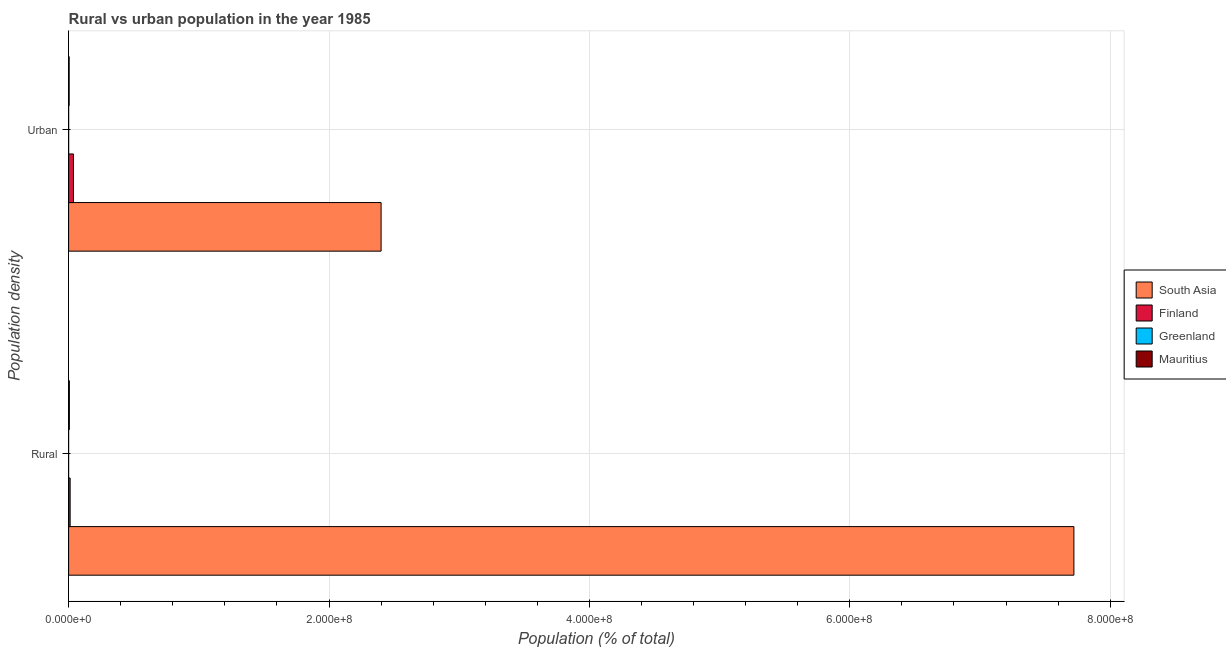How many different coloured bars are there?
Provide a short and direct response. 4. How many groups of bars are there?
Your response must be concise. 2. What is the label of the 2nd group of bars from the top?
Provide a succinct answer. Rural. What is the urban population density in Greenland?
Provide a succinct answer. 4.15e+04. Across all countries, what is the maximum urban population density?
Offer a terse response. 2.40e+08. Across all countries, what is the minimum rural population density?
Offer a terse response. 1.17e+04. In which country was the urban population density maximum?
Your answer should be very brief. South Asia. In which country was the rural population density minimum?
Make the answer very short. Greenland. What is the total rural population density in the graph?
Keep it short and to the point. 7.74e+08. What is the difference between the urban population density in Finland and that in Greenland?
Provide a short and direct response. 3.67e+06. What is the difference between the rural population density in Finland and the urban population density in South Asia?
Make the answer very short. -2.39e+08. What is the average urban population density per country?
Give a very brief answer. 6.10e+07. What is the difference between the rural population density and urban population density in Finland?
Provide a succinct answer. -2.53e+06. What is the ratio of the urban population density in Mauritius to that in Finland?
Provide a succinct answer. 0.12. Is the urban population density in Finland less than that in Mauritius?
Your answer should be very brief. No. In how many countries, is the urban population density greater than the average urban population density taken over all countries?
Keep it short and to the point. 1. What does the 3rd bar from the bottom in Urban represents?
Ensure brevity in your answer.  Greenland. How many countries are there in the graph?
Provide a succinct answer. 4. What is the difference between two consecutive major ticks on the X-axis?
Give a very brief answer. 2.00e+08. How many legend labels are there?
Give a very brief answer. 4. How are the legend labels stacked?
Provide a short and direct response. Vertical. What is the title of the graph?
Your response must be concise. Rural vs urban population in the year 1985. What is the label or title of the X-axis?
Offer a very short reply. Population (% of total). What is the label or title of the Y-axis?
Make the answer very short. Population density. What is the Population (% of total) of South Asia in Rural?
Provide a short and direct response. 7.72e+08. What is the Population (% of total) of Finland in Rural?
Make the answer very short. 1.19e+06. What is the Population (% of total) of Greenland in Rural?
Provide a succinct answer. 1.17e+04. What is the Population (% of total) in Mauritius in Rural?
Your answer should be very brief. 5.89e+05. What is the Population (% of total) in South Asia in Urban?
Offer a very short reply. 2.40e+08. What is the Population (% of total) in Finland in Urban?
Provide a short and direct response. 3.72e+06. What is the Population (% of total) in Greenland in Urban?
Your answer should be compact. 4.15e+04. What is the Population (% of total) in Mauritius in Urban?
Your answer should be compact. 4.32e+05. Across all Population density, what is the maximum Population (% of total) in South Asia?
Your answer should be compact. 7.72e+08. Across all Population density, what is the maximum Population (% of total) of Finland?
Give a very brief answer. 3.72e+06. Across all Population density, what is the maximum Population (% of total) in Greenland?
Make the answer very short. 4.15e+04. Across all Population density, what is the maximum Population (% of total) in Mauritius?
Your answer should be very brief. 5.89e+05. Across all Population density, what is the minimum Population (% of total) in South Asia?
Ensure brevity in your answer.  2.40e+08. Across all Population density, what is the minimum Population (% of total) in Finland?
Provide a succinct answer. 1.19e+06. Across all Population density, what is the minimum Population (% of total) in Greenland?
Ensure brevity in your answer.  1.17e+04. Across all Population density, what is the minimum Population (% of total) of Mauritius?
Your answer should be compact. 4.32e+05. What is the total Population (% of total) in South Asia in the graph?
Your response must be concise. 1.01e+09. What is the total Population (% of total) in Finland in the graph?
Give a very brief answer. 4.90e+06. What is the total Population (% of total) of Greenland in the graph?
Your response must be concise. 5.32e+04. What is the total Population (% of total) of Mauritius in the graph?
Give a very brief answer. 1.02e+06. What is the difference between the Population (% of total) of South Asia in Rural and that in Urban?
Ensure brevity in your answer.  5.32e+08. What is the difference between the Population (% of total) of Finland in Rural and that in Urban?
Offer a very short reply. -2.53e+06. What is the difference between the Population (% of total) of Greenland in Rural and that in Urban?
Offer a terse response. -2.98e+04. What is the difference between the Population (% of total) of Mauritius in Rural and that in Urban?
Provide a succinct answer. 1.57e+05. What is the difference between the Population (% of total) in South Asia in Rural and the Population (% of total) in Finland in Urban?
Make the answer very short. 7.68e+08. What is the difference between the Population (% of total) in South Asia in Rural and the Population (% of total) in Greenland in Urban?
Provide a short and direct response. 7.72e+08. What is the difference between the Population (% of total) of South Asia in Rural and the Population (% of total) of Mauritius in Urban?
Offer a terse response. 7.72e+08. What is the difference between the Population (% of total) in Finland in Rural and the Population (% of total) in Greenland in Urban?
Offer a very short reply. 1.14e+06. What is the difference between the Population (% of total) of Finland in Rural and the Population (% of total) of Mauritius in Urban?
Offer a terse response. 7.54e+05. What is the difference between the Population (% of total) in Greenland in Rural and the Population (% of total) in Mauritius in Urban?
Your answer should be very brief. -4.20e+05. What is the average Population (% of total) of South Asia per Population density?
Your answer should be compact. 5.06e+08. What is the average Population (% of total) in Finland per Population density?
Offer a very short reply. 2.45e+06. What is the average Population (% of total) of Greenland per Population density?
Ensure brevity in your answer.  2.66e+04. What is the average Population (% of total) in Mauritius per Population density?
Ensure brevity in your answer.  5.10e+05. What is the difference between the Population (% of total) of South Asia and Population (% of total) of Finland in Rural?
Give a very brief answer. 7.71e+08. What is the difference between the Population (% of total) in South Asia and Population (% of total) in Greenland in Rural?
Offer a very short reply. 7.72e+08. What is the difference between the Population (% of total) in South Asia and Population (% of total) in Mauritius in Rural?
Provide a short and direct response. 7.72e+08. What is the difference between the Population (% of total) of Finland and Population (% of total) of Greenland in Rural?
Give a very brief answer. 1.17e+06. What is the difference between the Population (% of total) in Finland and Population (% of total) in Mauritius in Rural?
Ensure brevity in your answer.  5.97e+05. What is the difference between the Population (% of total) of Greenland and Population (% of total) of Mauritius in Rural?
Ensure brevity in your answer.  -5.77e+05. What is the difference between the Population (% of total) of South Asia and Population (% of total) of Finland in Urban?
Your answer should be very brief. 2.36e+08. What is the difference between the Population (% of total) of South Asia and Population (% of total) of Greenland in Urban?
Your answer should be compact. 2.40e+08. What is the difference between the Population (% of total) of South Asia and Population (% of total) of Mauritius in Urban?
Ensure brevity in your answer.  2.40e+08. What is the difference between the Population (% of total) in Finland and Population (% of total) in Greenland in Urban?
Give a very brief answer. 3.67e+06. What is the difference between the Population (% of total) in Finland and Population (% of total) in Mauritius in Urban?
Offer a very short reply. 3.28e+06. What is the difference between the Population (% of total) of Greenland and Population (% of total) of Mauritius in Urban?
Offer a terse response. -3.90e+05. What is the ratio of the Population (% of total) in South Asia in Rural to that in Urban?
Keep it short and to the point. 3.22. What is the ratio of the Population (% of total) in Finland in Rural to that in Urban?
Ensure brevity in your answer.  0.32. What is the ratio of the Population (% of total) in Greenland in Rural to that in Urban?
Provide a succinct answer. 0.28. What is the ratio of the Population (% of total) in Mauritius in Rural to that in Urban?
Provide a succinct answer. 1.36. What is the difference between the highest and the second highest Population (% of total) of South Asia?
Your answer should be very brief. 5.32e+08. What is the difference between the highest and the second highest Population (% of total) in Finland?
Offer a terse response. 2.53e+06. What is the difference between the highest and the second highest Population (% of total) of Greenland?
Make the answer very short. 2.98e+04. What is the difference between the highest and the second highest Population (% of total) of Mauritius?
Ensure brevity in your answer.  1.57e+05. What is the difference between the highest and the lowest Population (% of total) of South Asia?
Give a very brief answer. 5.32e+08. What is the difference between the highest and the lowest Population (% of total) of Finland?
Make the answer very short. 2.53e+06. What is the difference between the highest and the lowest Population (% of total) in Greenland?
Provide a short and direct response. 2.98e+04. What is the difference between the highest and the lowest Population (% of total) of Mauritius?
Make the answer very short. 1.57e+05. 